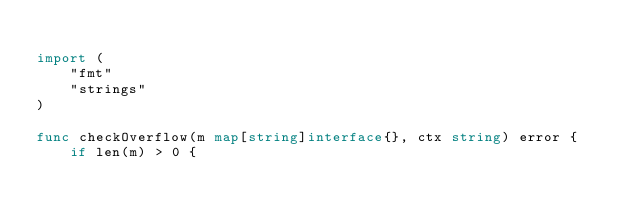<code> <loc_0><loc_0><loc_500><loc_500><_Go_>
import (
	"fmt"
	"strings"
)

func checkOverflow(m map[string]interface{}, ctx string) error {
	if len(m) > 0 {</code> 